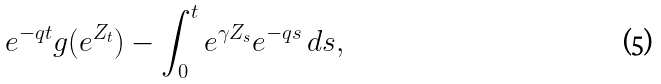Convert formula to latex. <formula><loc_0><loc_0><loc_500><loc_500>e ^ { - q t } g ( e ^ { Z _ { t } } ) - \int _ { 0 } ^ { t } e ^ { \gamma Z _ { s } } e ^ { - q s } \, d s ,</formula> 